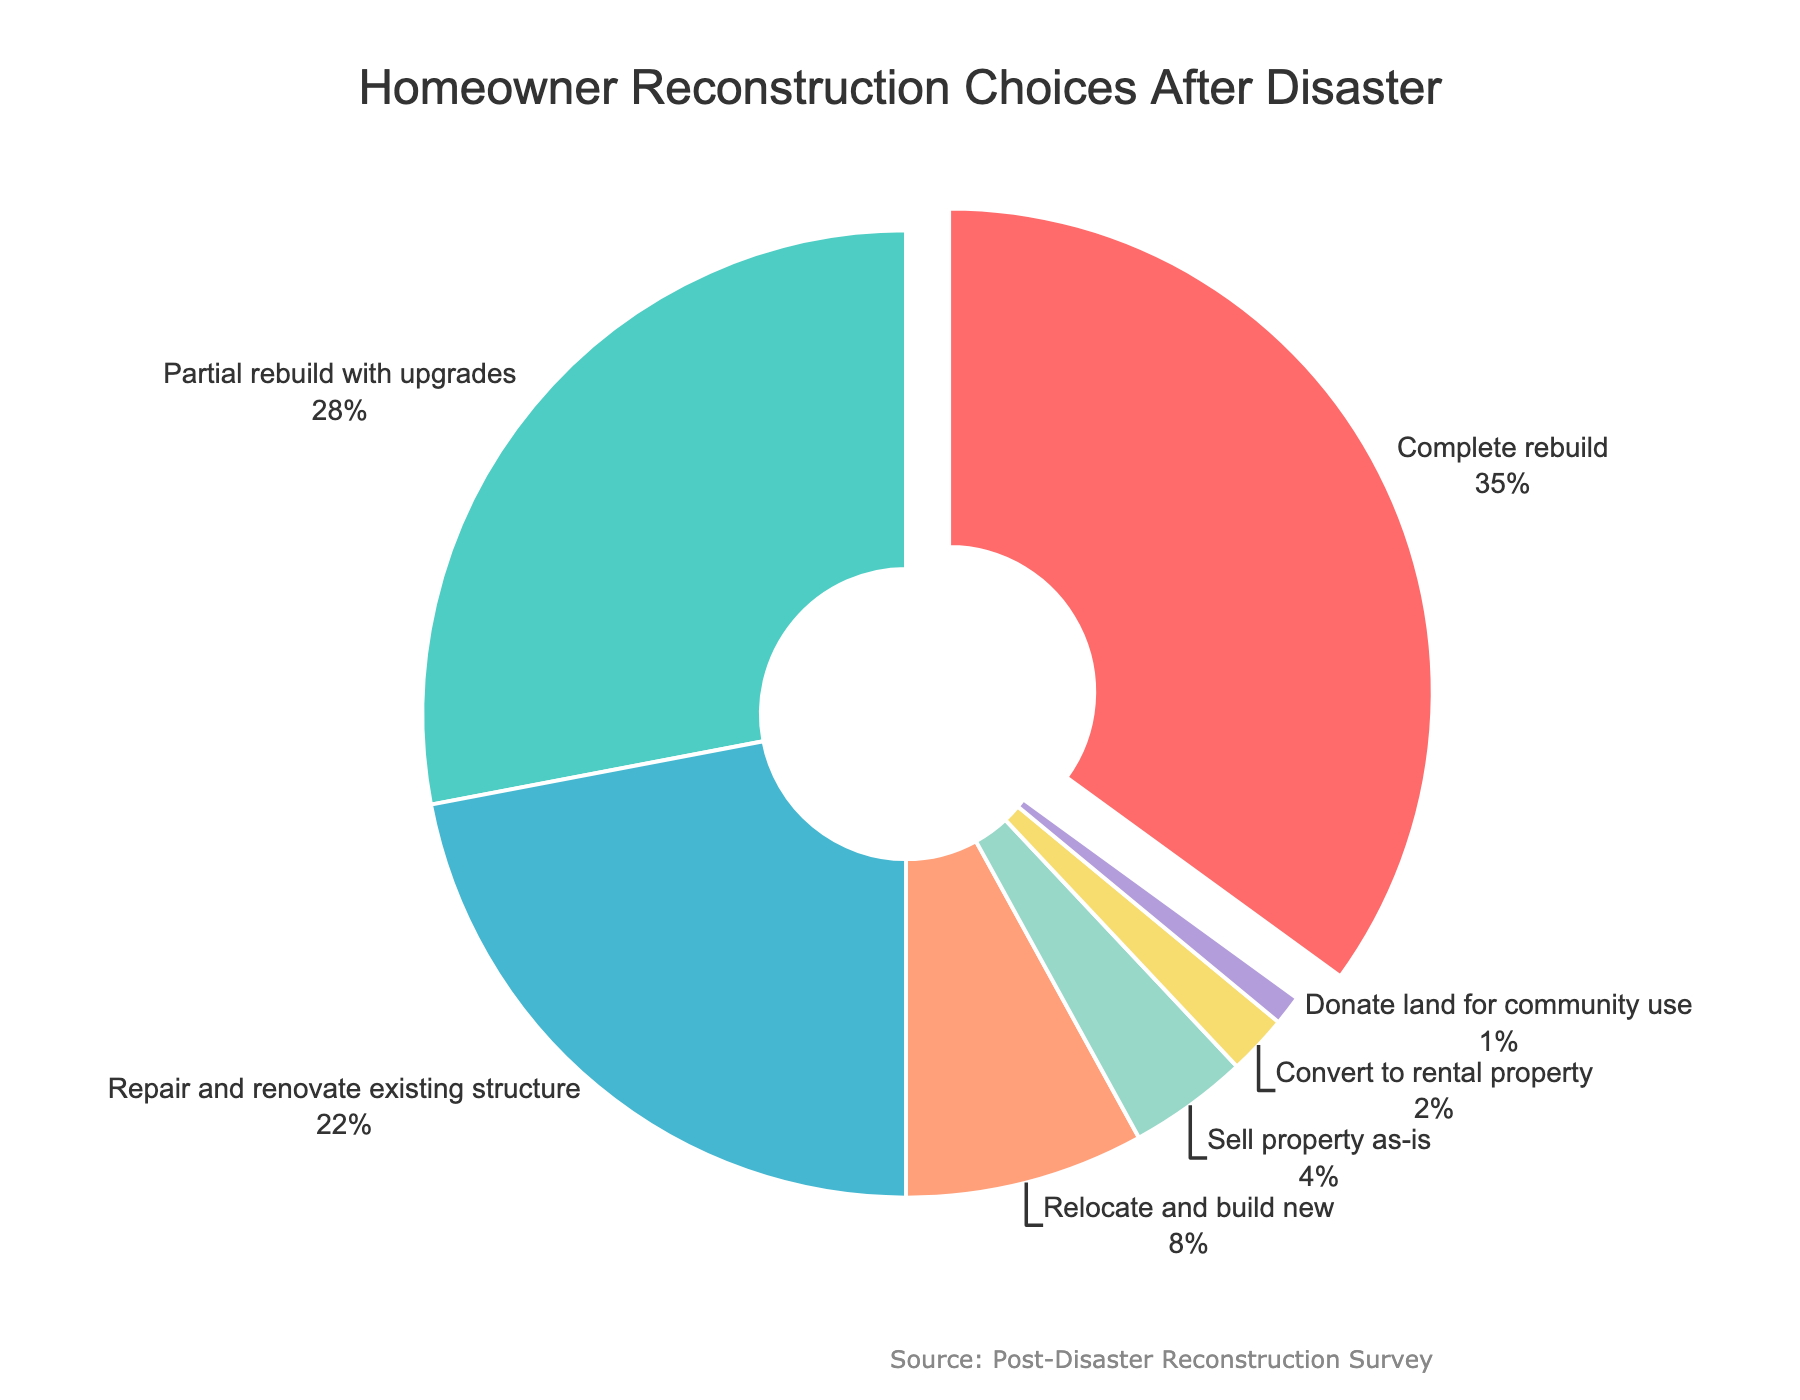What percentage of homeowners chose to sell their property as-is? To find the percentage of homeowners who chose to sell their property as-is, look at the slice labeled 'Sell property as-is'. The percentage is written next to the label.
Answer: 4% Which reconstruction option was chosen by the largest percentage of homeowners? Check all the segments of the pie chart and identify the one with the largest size. The option label should indicate the highest percentage.
Answer: Complete rebuild How much more popular is a complete rebuild compared to relocating and building new? Find the percentages for both 'Complete rebuild' and 'Relocate and build new'. Subtract the smaller percentage from the larger percentage to get the difference.
Answer: 27% What are the two least popular reconstruction options and their combined percentage? Identify the two smallest segments in the pie chart. Check their labels for the options and percentages, then add the two percentages together.
Answer: Donate land for community use and Convert to rental property, 3% Compare the popularity of partial rebuild with upgrades and repair and renovate existing structure. Which one is more popular and by how much? Find the percentage for both 'Partial rebuild with upgrades' and 'Repair and renovate existing structure'. Subtract the smaller percentage from the larger one to find the difference.
Answer: Partial rebuild with upgrades by 6% What percentage of homeowners opted for either converting their property to a rental property or donating the land for community use? Find the segments for 'Convert to rental property' and 'Donate land for community use'. Add their percentages together.
Answer: 3% Is the percentage of homeowners who chose to repair and renovate their existing structure greater than those who chose to relocate and build new? Compare the percentages for 'Repair and renovate existing structure' and 'Relocate and build new' to see which is larger.
Answer: Yes Which option, if combined with complete rebuild, makes up more than half of the total choices? Determine the percentage of 'Complete rebuild' and find an option where, when combined with 'Complete rebuild', their sum is greater than 50%.
Answer: Partial rebuild with upgrades Identify the segment with a pulled-out slice and its percentage. Look for the segment of the pie chart that is slightly separated from the rest (pulled out) and check its label for the percentage.
Answer: Complete rebuild, 35% 